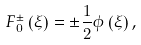Convert formula to latex. <formula><loc_0><loc_0><loc_500><loc_500>{ F _ { 0 } ^ { \pm } } \left ( \xi \right ) = \pm { \frac { 1 } { 2 } } \phi \left ( \xi \right ) ,</formula> 